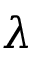<formula> <loc_0><loc_0><loc_500><loc_500>\lambda</formula> 